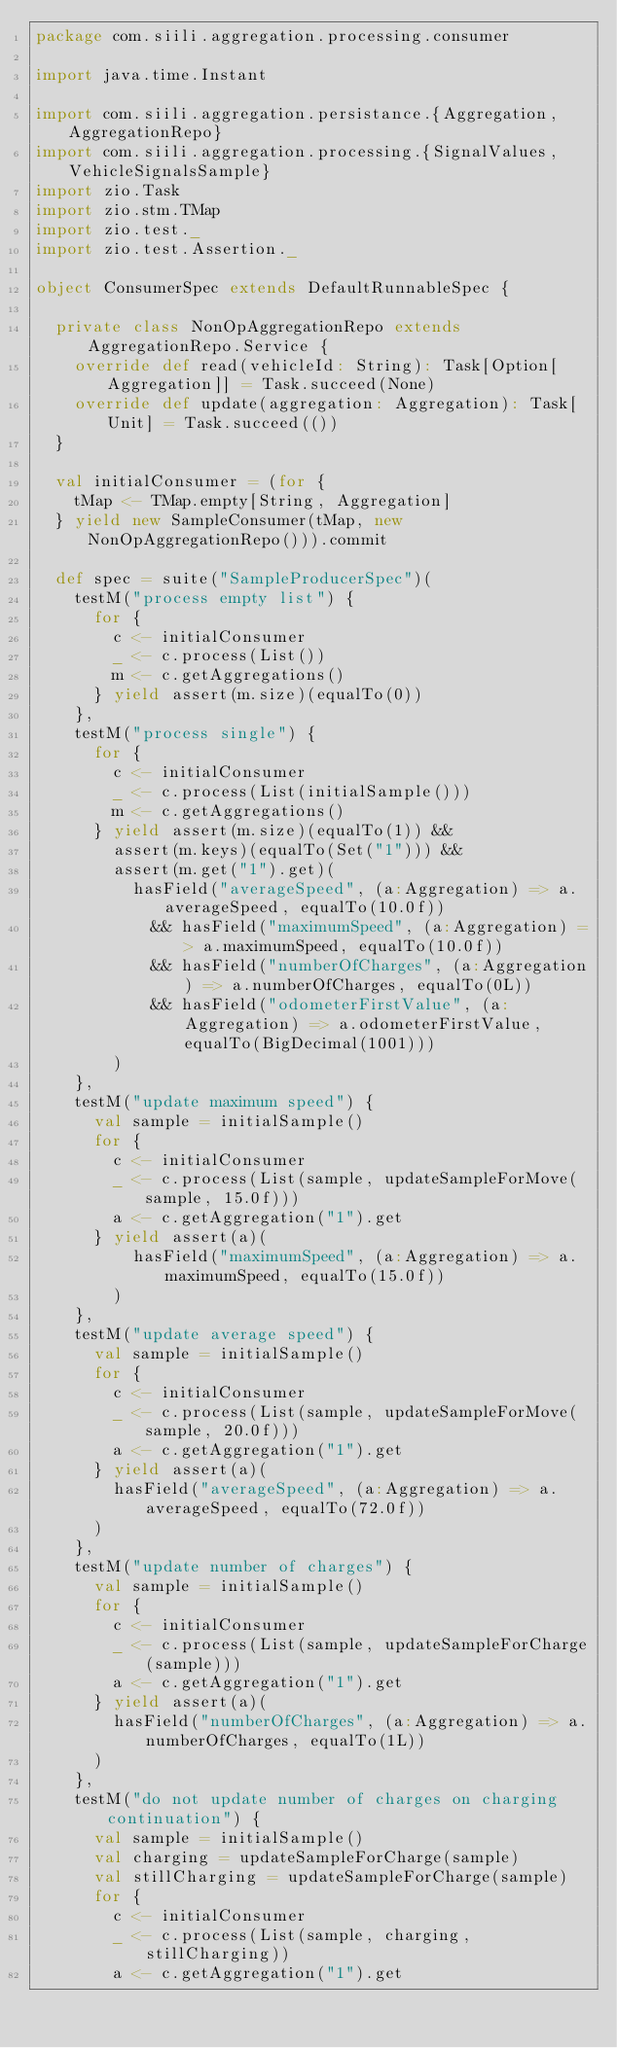<code> <loc_0><loc_0><loc_500><loc_500><_Scala_>package com.siili.aggregation.processing.consumer

import java.time.Instant

import com.siili.aggregation.persistance.{Aggregation, AggregationRepo}
import com.siili.aggregation.processing.{SignalValues, VehicleSignalsSample}
import zio.Task
import zio.stm.TMap
import zio.test._
import zio.test.Assertion._

object ConsumerSpec extends DefaultRunnableSpec {

  private class NonOpAggregationRepo extends AggregationRepo.Service {
    override def read(vehicleId: String): Task[Option[Aggregation]] = Task.succeed(None)
    override def update(aggregation: Aggregation): Task[Unit] = Task.succeed(())
  }

  val initialConsumer = (for {
    tMap <- TMap.empty[String, Aggregation]
  } yield new SampleConsumer(tMap, new NonOpAggregationRepo())).commit

  def spec = suite("SampleProducerSpec")(
    testM("process empty list") {
      for {
        c <- initialConsumer
        _ <- c.process(List())
        m <- c.getAggregations()
      } yield assert(m.size)(equalTo(0))
    },
    testM("process single") {
      for {
        c <- initialConsumer
        _ <- c.process(List(initialSample()))
        m <- c.getAggregations()
      } yield assert(m.size)(equalTo(1)) &&
        assert(m.keys)(equalTo(Set("1"))) &&
        assert(m.get("1").get)(
          hasField("averageSpeed", (a:Aggregation) => a.averageSpeed, equalTo(10.0f))
            && hasField("maximumSpeed", (a:Aggregation) => a.maximumSpeed, equalTo(10.0f))
            && hasField("numberOfCharges", (a:Aggregation) => a.numberOfCharges, equalTo(0L))
            && hasField("odometerFirstValue", (a:Aggregation) => a.odometerFirstValue, equalTo(BigDecimal(1001)))
        )
    },
    testM("update maximum speed") {
      val sample = initialSample()
      for {
        c <- initialConsumer
        _ <- c.process(List(sample, updateSampleForMove(sample, 15.0f)))
        a <- c.getAggregation("1").get
      } yield assert(a)(
          hasField("maximumSpeed", (a:Aggregation) => a.maximumSpeed, equalTo(15.0f))
        )
    },
    testM("update average speed") {
      val sample = initialSample()
      for {
        c <- initialConsumer
        _ <- c.process(List(sample, updateSampleForMove(sample, 20.0f)))
        a <- c.getAggregation("1").get
      } yield assert(a)(
        hasField("averageSpeed", (a:Aggregation) => a.averageSpeed, equalTo(72.0f))
      )
    },
    testM("update number of charges") {
      val sample = initialSample()
      for {
        c <- initialConsumer
        _ <- c.process(List(sample, updateSampleForCharge(sample)))
        a <- c.getAggregation("1").get
      } yield assert(a)(
        hasField("numberOfCharges", (a:Aggregation) => a.numberOfCharges, equalTo(1L))
      )
    },
    testM("do not update number of charges on charging continuation") {
      val sample = initialSample()
      val charging = updateSampleForCharge(sample)
      val stillCharging = updateSampleForCharge(sample)
      for {
        c <- initialConsumer
        _ <- c.process(List(sample, charging, stillCharging))
        a <- c.getAggregation("1").get</code> 